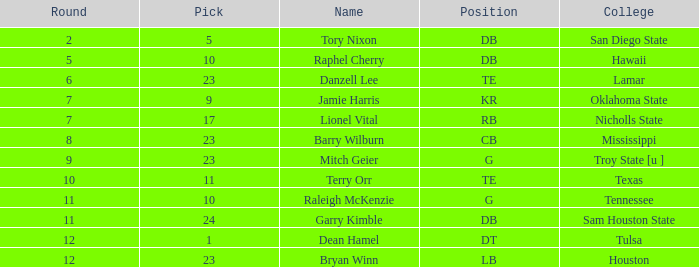Which round has the highest number with a pick under 10 and a name of tory nixon? 2.0. 